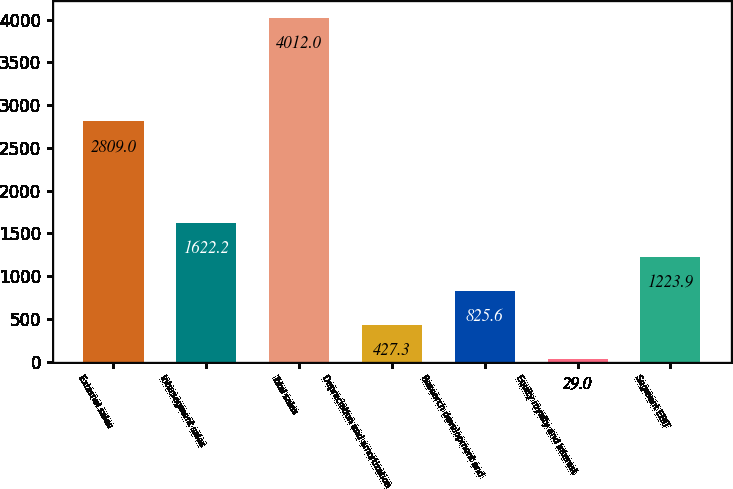Convert chart to OTSL. <chart><loc_0><loc_0><loc_500><loc_500><bar_chart><fcel>External sales<fcel>Intersegment sales<fcel>Total sales<fcel>Depreciation and amortization<fcel>Research development and<fcel>Equity royalty and interest<fcel>Segment EBIT<nl><fcel>2809<fcel>1622.2<fcel>4012<fcel>427.3<fcel>825.6<fcel>29<fcel>1223.9<nl></chart> 